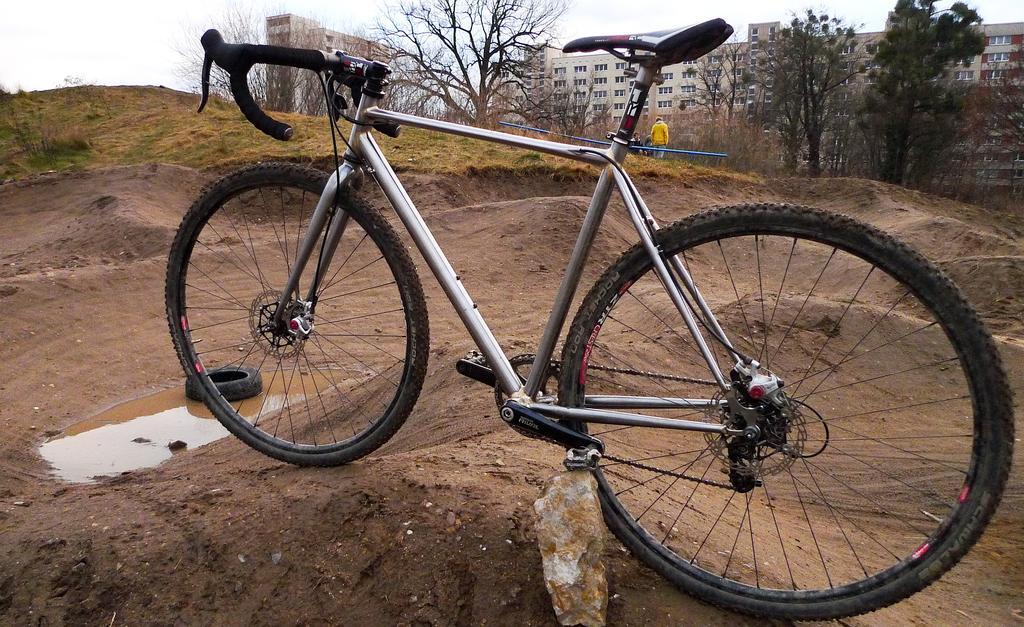Can you describe this image briefly? In this image there is cycle which is parked on the sand. In front of the cycle there is water. In the water there is a Tyre. In the background there are so many buildings and trees in between them. 